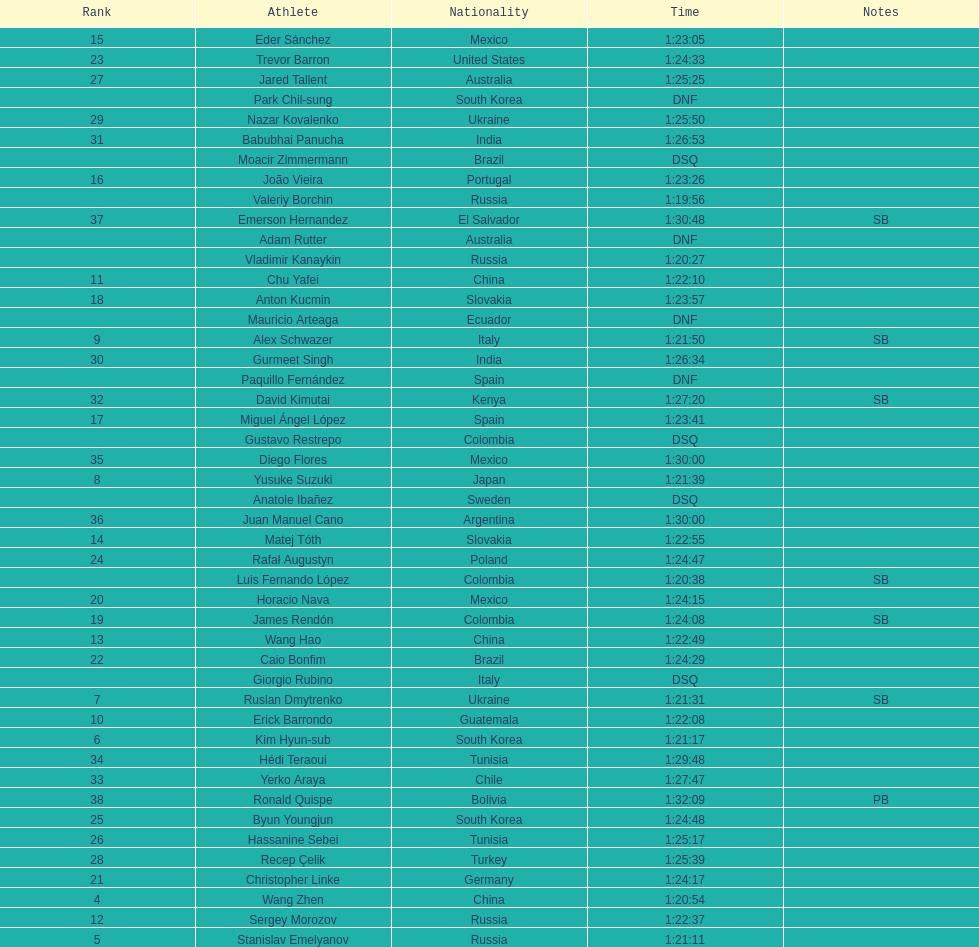What is the total count of athletes included in the rankings chart, including those classified as dsq & dnf? 46. 